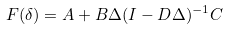Convert formula to latex. <formula><loc_0><loc_0><loc_500><loc_500>F ( \delta ) = A + B \Delta ( I - D \Delta ) ^ { - 1 } C</formula> 